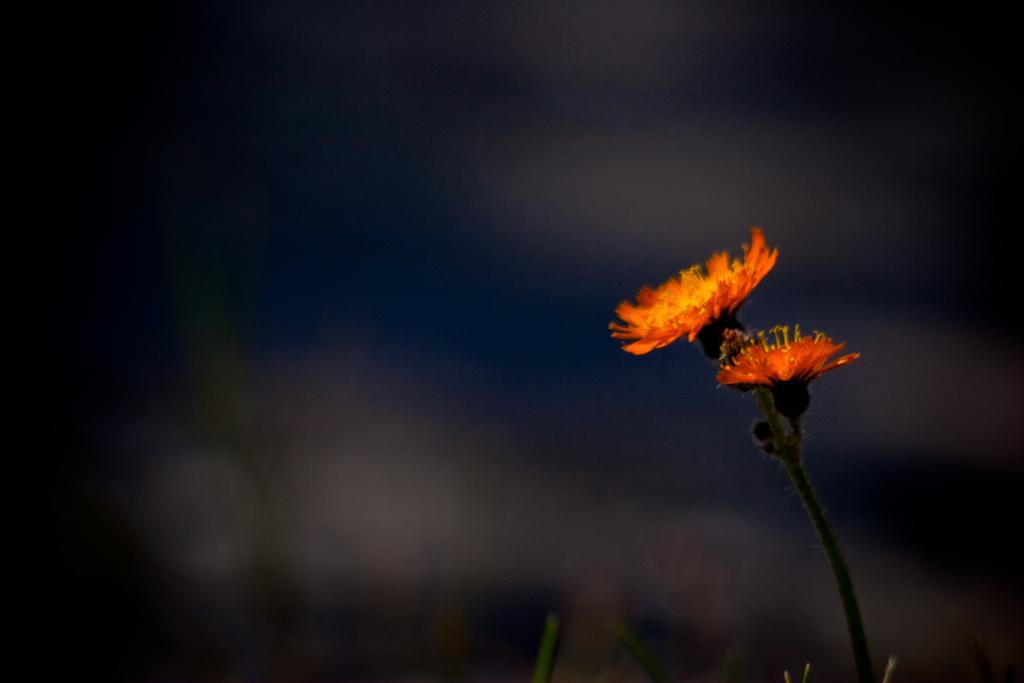Could you give a brief overview of what you see in this image? In this image there is a sunflower at right side of this image. 